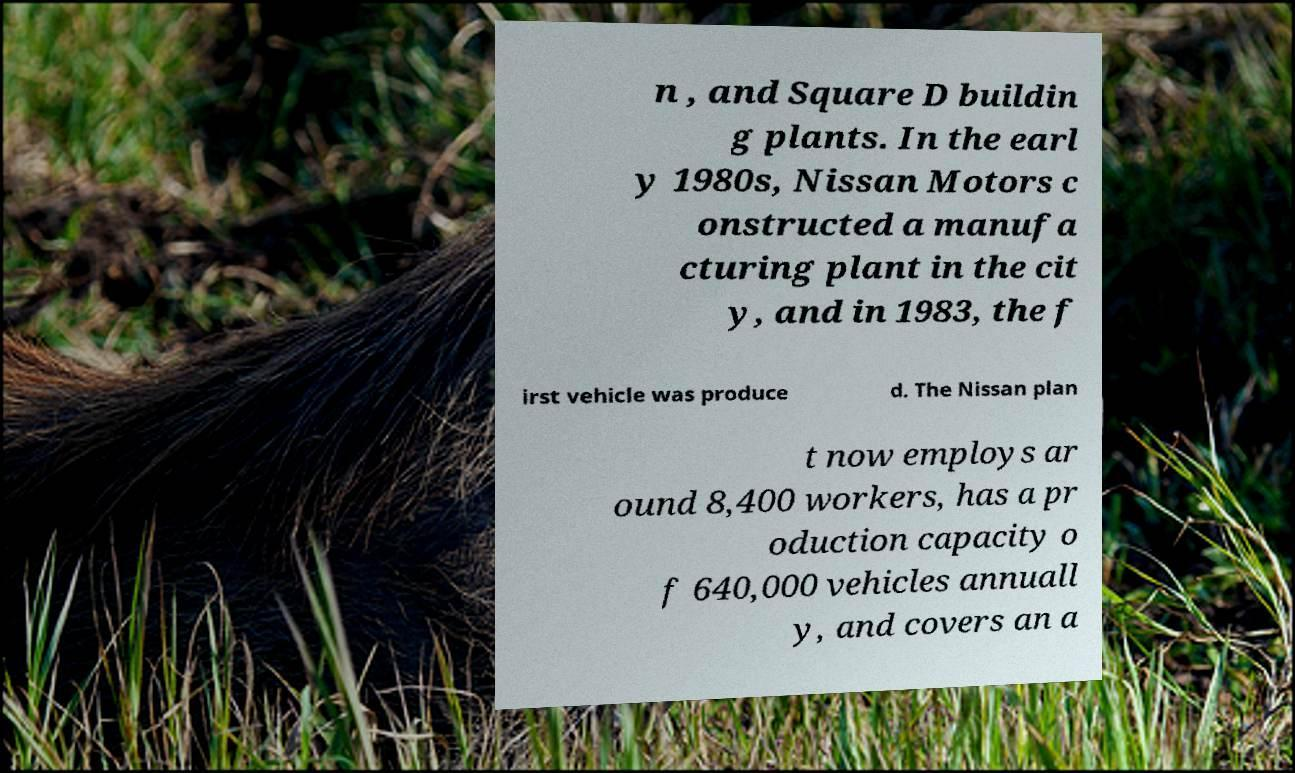Please identify and transcribe the text found in this image. n , and Square D buildin g plants. In the earl y 1980s, Nissan Motors c onstructed a manufa cturing plant in the cit y, and in 1983, the f irst vehicle was produce d. The Nissan plan t now employs ar ound 8,400 workers, has a pr oduction capacity o f 640,000 vehicles annuall y, and covers an a 